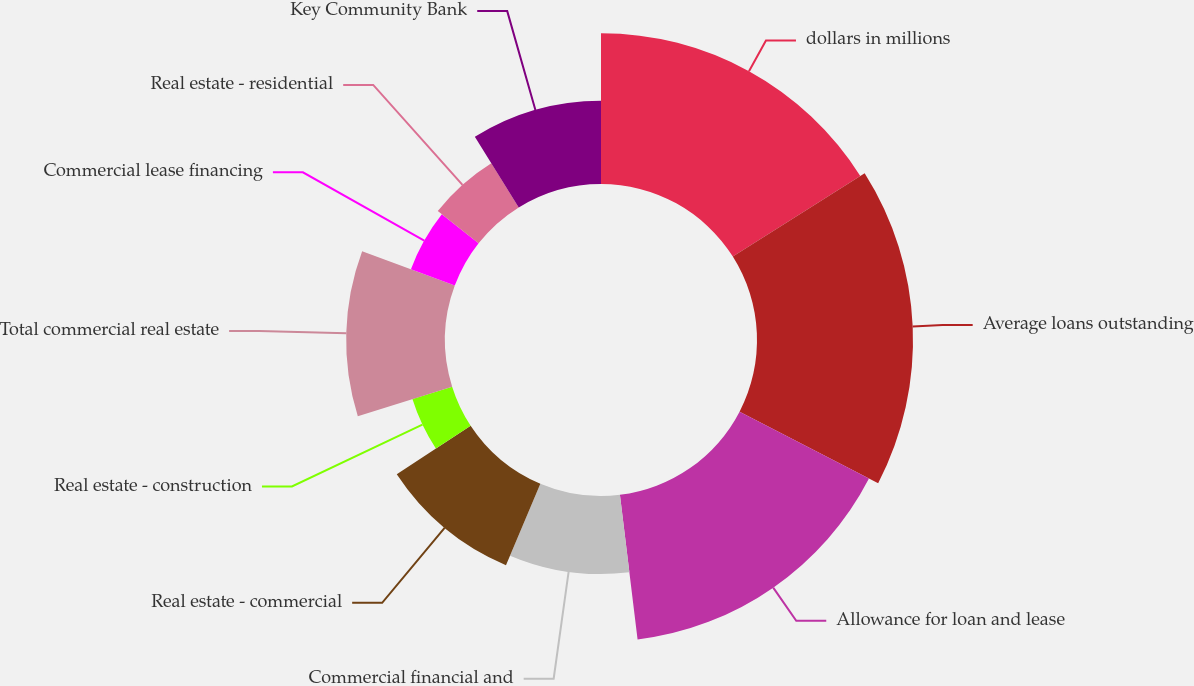Convert chart. <chart><loc_0><loc_0><loc_500><loc_500><pie_chart><fcel>dollars in millions<fcel>Average loans outstanding<fcel>Allowance for loan and lease<fcel>Commercial financial and<fcel>Real estate - commercial<fcel>Real estate - construction<fcel>Total commercial real estate<fcel>Commercial lease financing<fcel>Real estate - residential<fcel>Key Community Bank<nl><fcel>16.02%<fcel>16.57%<fcel>15.47%<fcel>8.29%<fcel>9.39%<fcel>4.42%<fcel>10.5%<fcel>4.97%<fcel>5.52%<fcel>8.84%<nl></chart> 